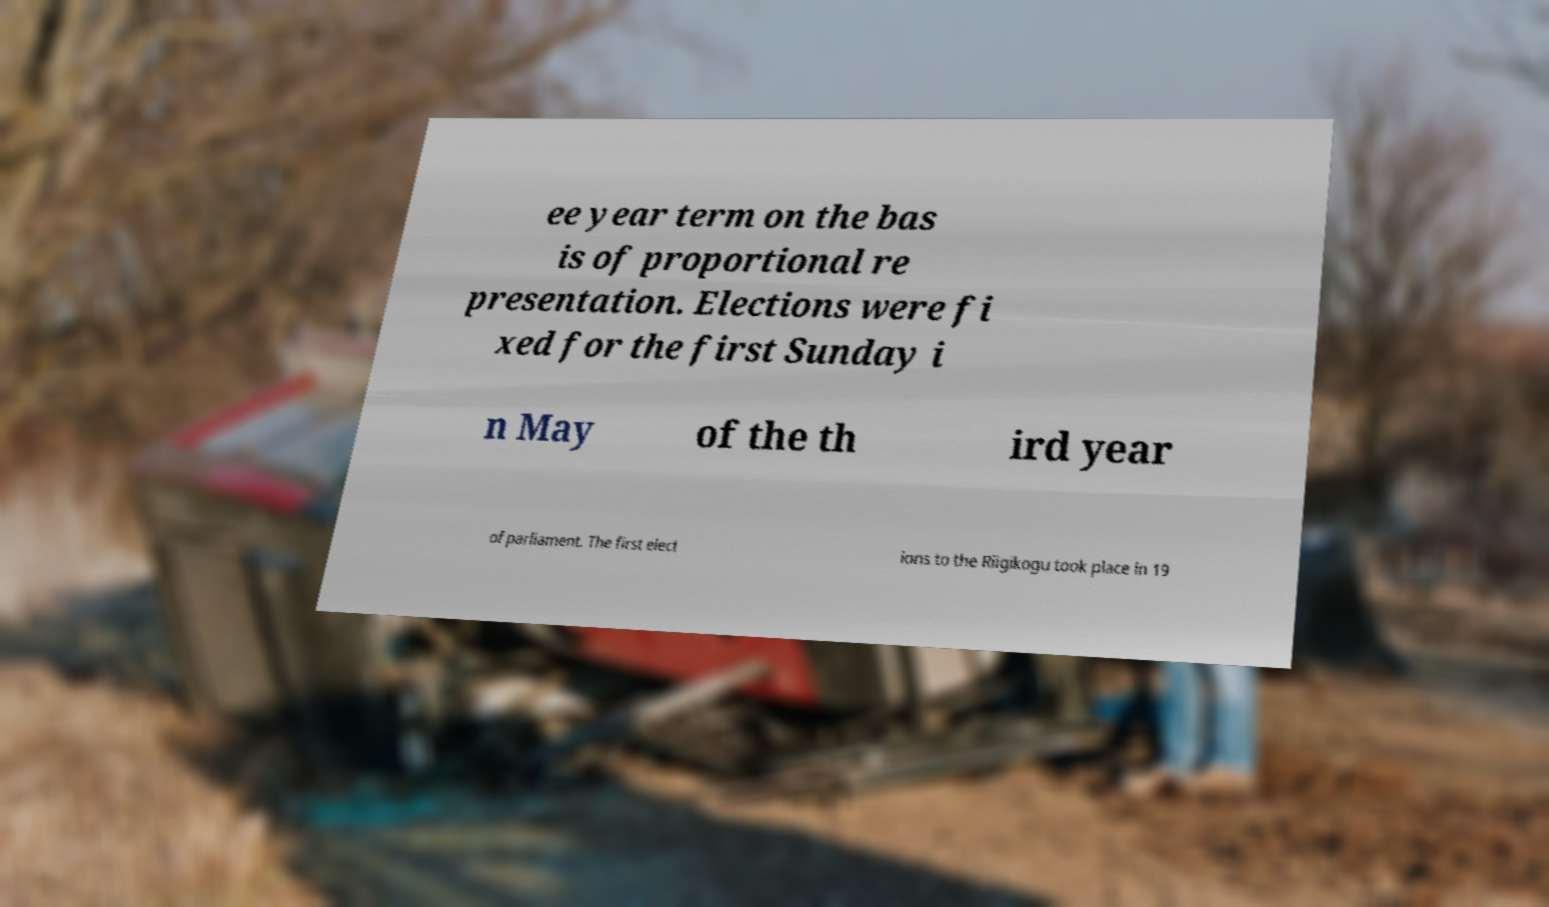Can you accurately transcribe the text from the provided image for me? ee year term on the bas is of proportional re presentation. Elections were fi xed for the first Sunday i n May of the th ird year of parliament. The first elect ions to the Riigikogu took place in 19 